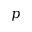Convert formula to latex. <formula><loc_0><loc_0><loc_500><loc_500>p</formula> 